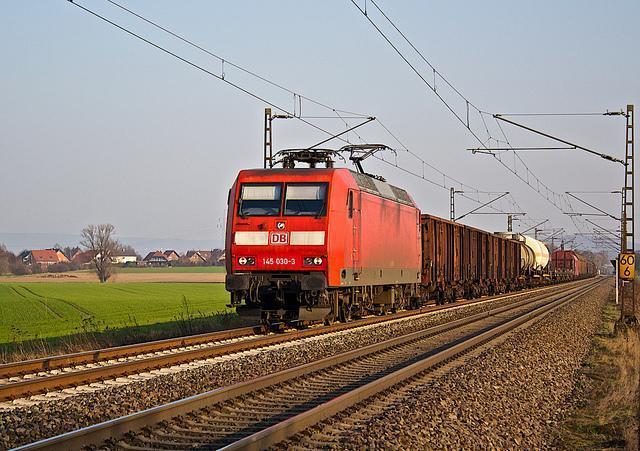How many trains are there?
Give a very brief answer. 1. How many people are listening to music?
Give a very brief answer. 0. 